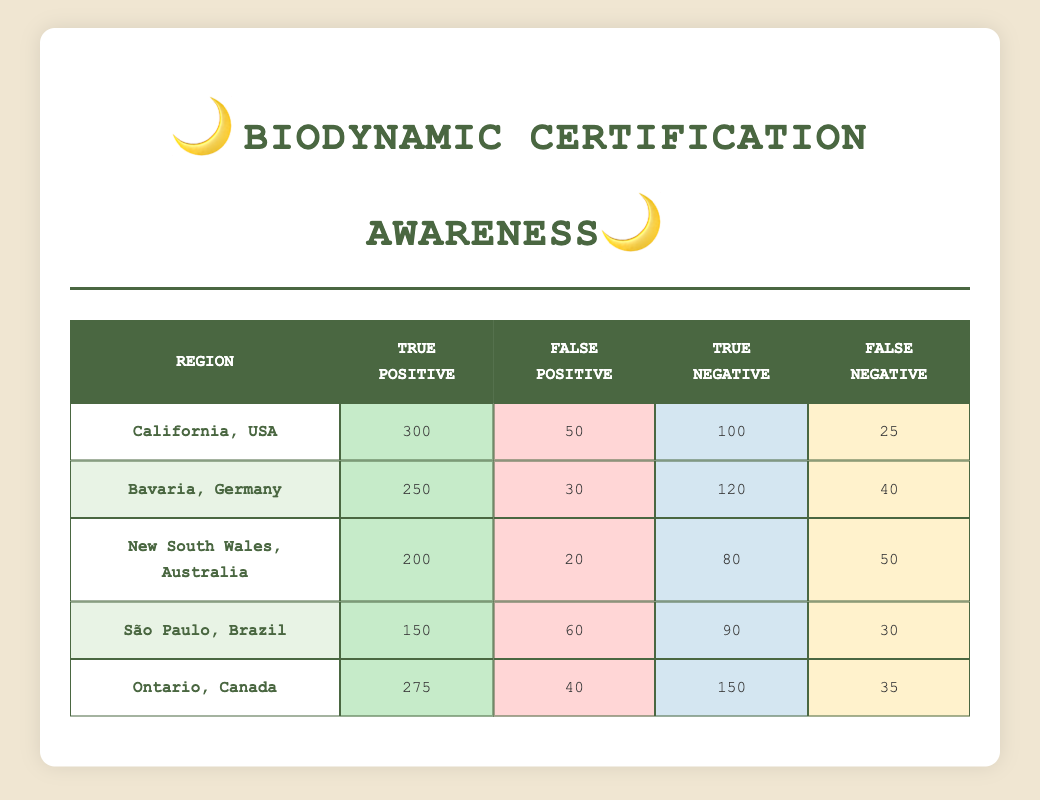What is the true positive count for California, USA? In the table, under the "California, USA" row, the "True Positive" value is explicitly listed as 300.
Answer: 300 What is the false negative count for São Paulo, Brazil? The "False Negative" count for São Paulo, Brazil, is provided in the relevant row of the table. It shows a value of 30.
Answer: 30 Which region has the highest number of true positives? By comparing the "True Positive" values across all regions, California, USA has the highest score of 300, followed by Ontario, Canada with 275.
Answer: California, USA What is the average number of true negatives across all regions? To calculate the average, add the "True Negative" values (100 + 120 + 80 + 90 + 150 = 540) and divide by the number of regions (5). Therefore, the average is 540 / 5 = 108.
Answer: 108 Is the false positive count for New South Wales, Australia greater than for Bavaria, Germany? The "False Positive" count for New South Wales is 20 and for Bavaria is 30. Since 20 is less than 30, the statement is false.
Answer: No What is the total count of false positives across all regions? By summing the "False Positive" values (50 + 30 + 20 + 60 + 40 = 200), the total count of false positives across all regions is calculated.
Answer: 200 In which region is the ratio of true positives to false negatives the highest? The ratio is calculated for each region by taking the "True Positive" divided by "False Negative": California (300/25 = 12), Bavaria (250/40 = 6.25), New South Wales (200/50 = 4), São Paulo (150/30 = 5), and Ontario (275/35 = 7.86). The highest ratio is found in California, USA with a ratio of 12.
Answer: California, USA What is the total number of true positives for regions with more than 200 true positives? The relevant regions are California (300) and Ontario (275). Their true positives sum to 575 (300 + 275).
Answer: 575 Does Ontario, Canada have a higher number of true positives than New South Wales, Australia? Comparing the "True Positive" values, Ontario has 275 while New South Wales has 200. Since 275 is greater than 200, the statement is true.
Answer: Yes 